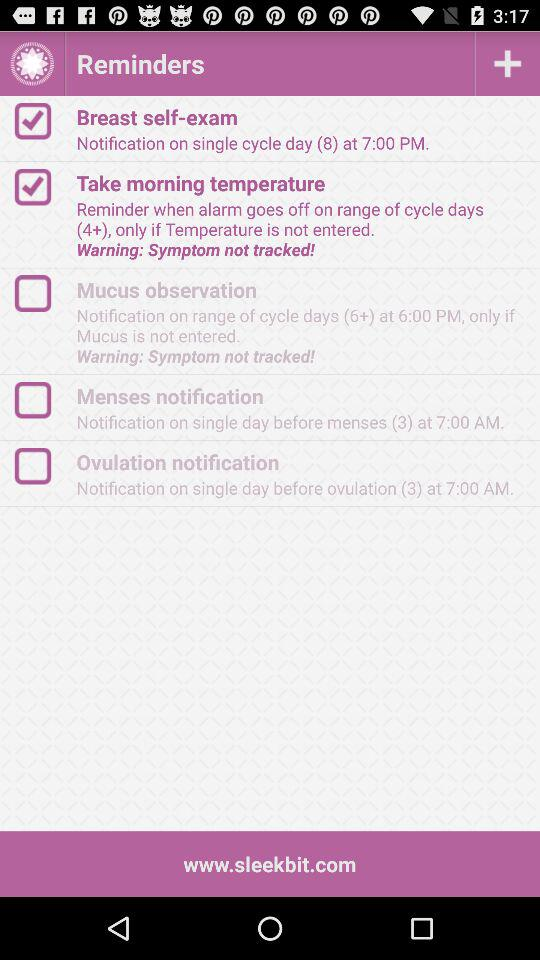Where is the number for customer support?
When the provided information is insufficient, respond with <no answer>. <no answer> 